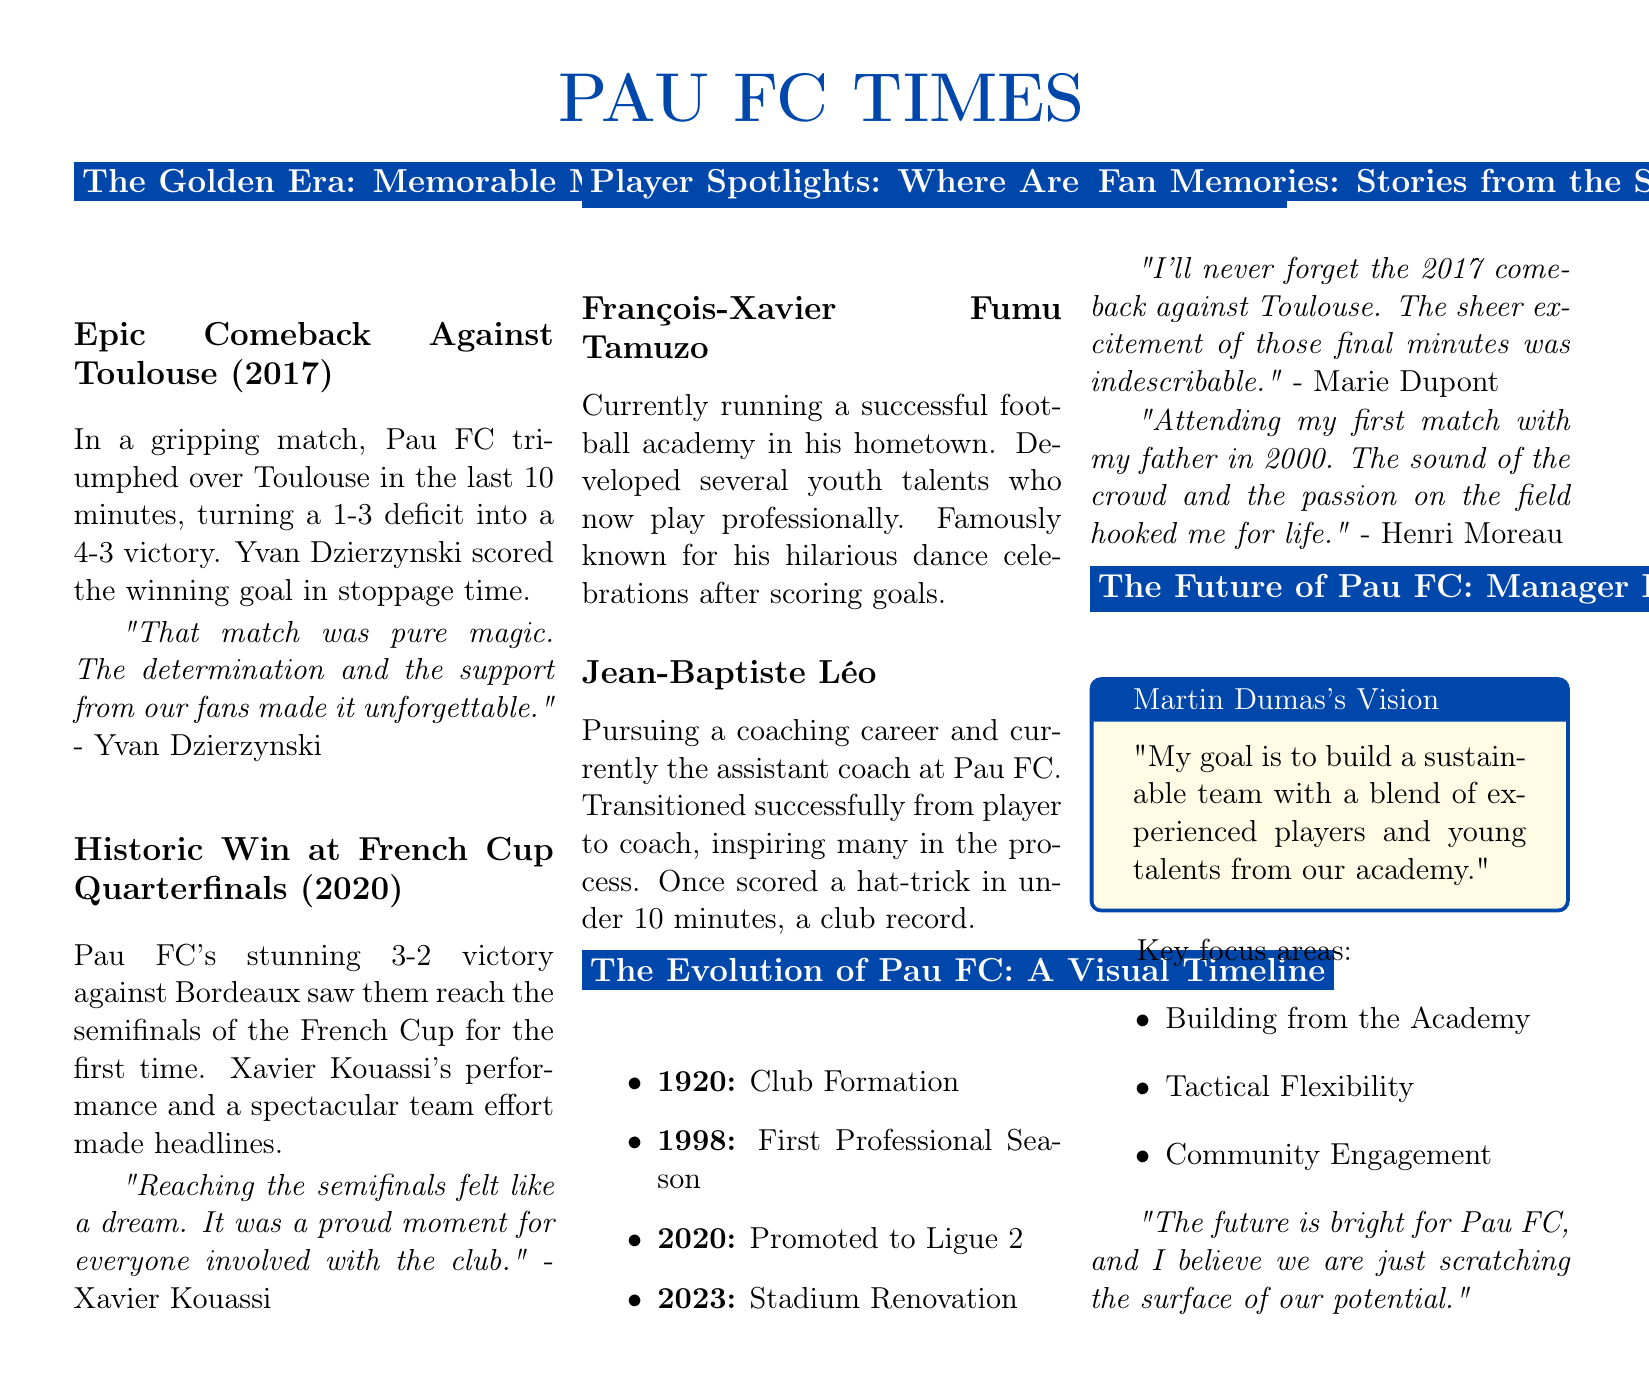What was Pau FC's score against Toulouse in 2017? The score of the match against Toulouse was a comeback from a 1-3 deficit to a 4-3 victory.
Answer: 4-3 Who scored the winning goal in the Toulouse match? The document states that Yvan Dzierzynski scored the winning goal in stoppage time.
Answer: Yvan Dzierzynski What year did Pau FC reach the French Cup semifinals? The document says Pau FC reached the semifinals of the French Cup for the first time in 2020.
Answer: 2020 What team did Pau FC defeat in the historic Quarterfinals? The match summary mentions that Pau FC defeated Bordeaux in the Quarterfinals.
Answer: Bordeaux What is François-Xavier Fumu Tamuzo currently doing? According to the document, he is running a successful football academy in his hometown.
Answer: Football academy What is Martin Dumas's main goal for the team? The document indicates that his goal is to build a sustainable team with a blend of experienced players and young talents.
Answer: Build a sustainable team Which year marks the formation of Pau FC? The timeline shows that the club was formed in 1920.
Answer: 1920 What record did Jean-Baptiste Léo hold during his playing days? The document notes that he once scored a hat-trick in under 10 minutes, a club record.
Answer: Hat-trick in under 10 minutes What are the key areas of focus for future development highlighted in the interview? The document lists building from the academy, tactical flexibility, and community engagement as focus areas.
Answer: Academy, tactical flexibility, community engagement 